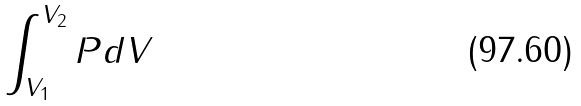<formula> <loc_0><loc_0><loc_500><loc_500>\int _ { V _ { 1 } } ^ { V _ { 2 } } P d V</formula> 